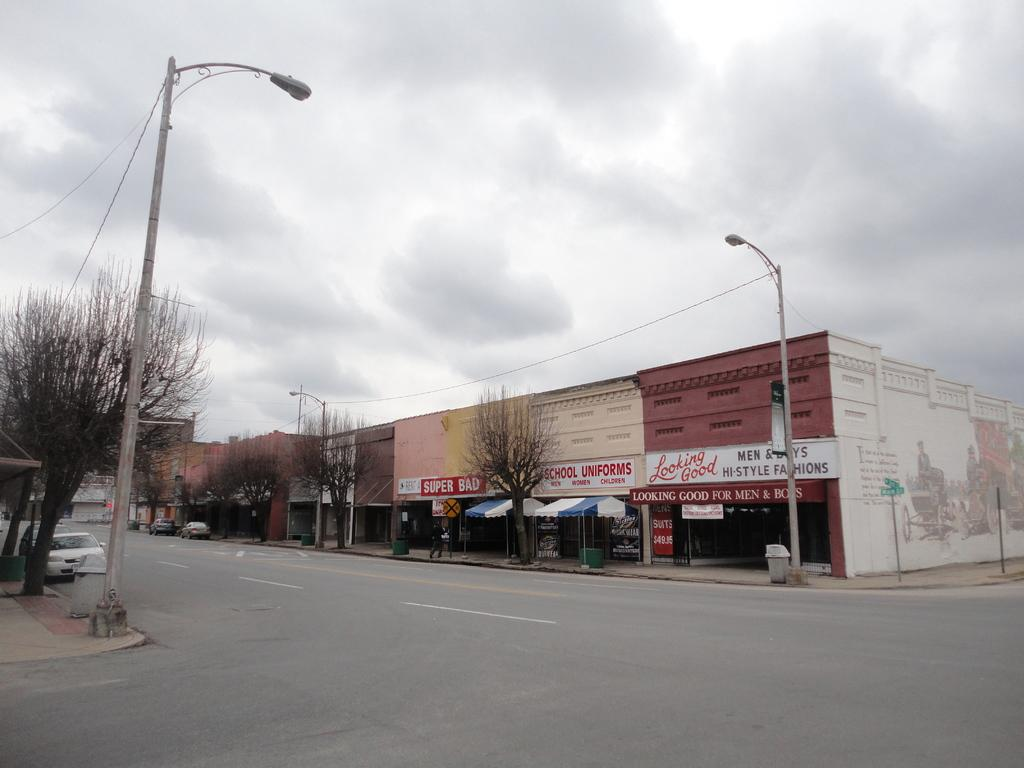What is happening on the road in the image? There are vehicles on the road in the image. What are the people in the image doing? There are people walking on a pathway in the image. What can be seen beside the road in the image? There are poles, lights, trees, and hoardings beside the road in the image. What type of structures are located beside the road in the image? There are houses beside the road in the image. What type of blade is being used by the committee in the image? There is no committee or blade present in the image. Can you make a comparison between the houses and the trees in the image? The question cannot be answered definitively as it requires a comparison, which is not possible based on the provided facts. 